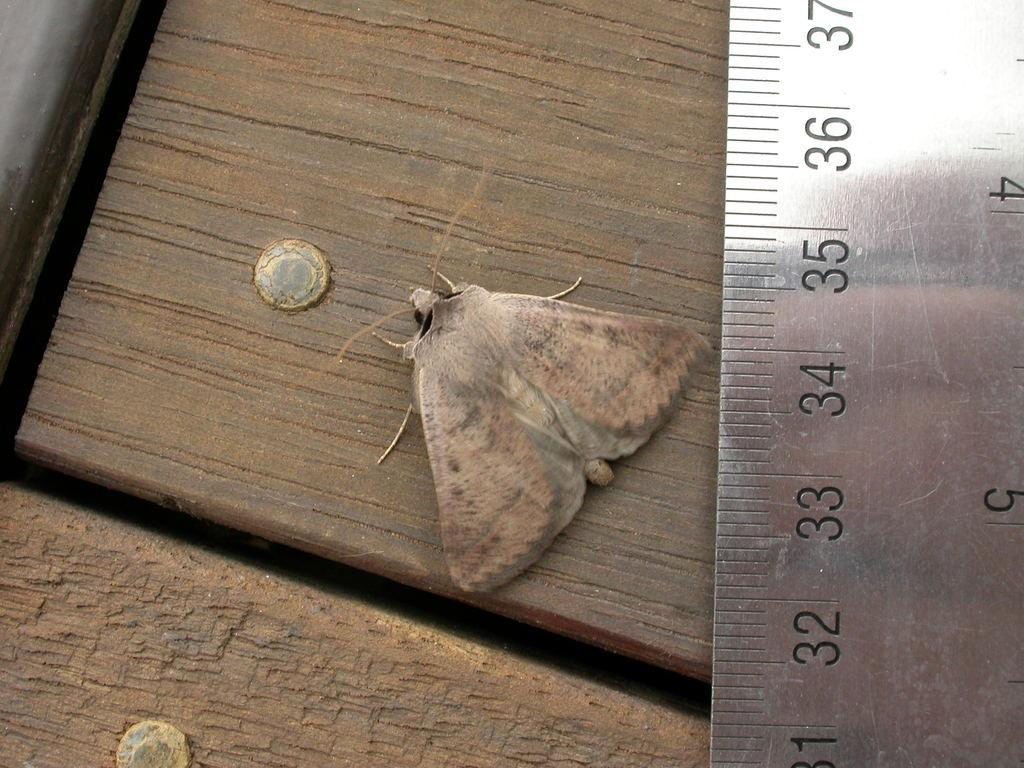<image>
Present a compact description of the photo's key features. Moth sitting next to a ruler that has black number 34 on it. 